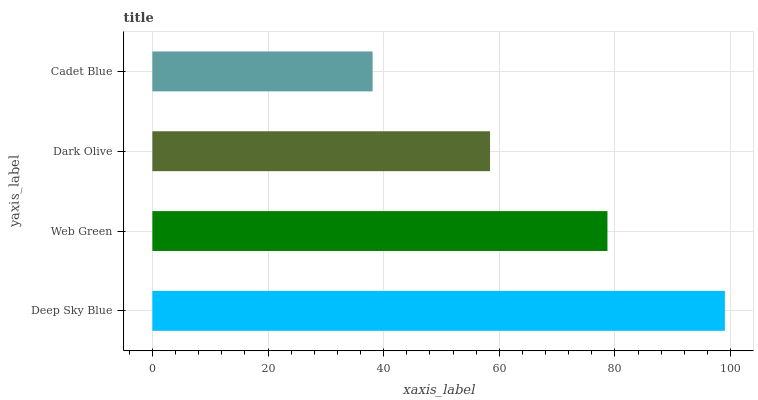Is Cadet Blue the minimum?
Answer yes or no. Yes. Is Deep Sky Blue the maximum?
Answer yes or no. Yes. Is Web Green the minimum?
Answer yes or no. No. Is Web Green the maximum?
Answer yes or no. No. Is Deep Sky Blue greater than Web Green?
Answer yes or no. Yes. Is Web Green less than Deep Sky Blue?
Answer yes or no. Yes. Is Web Green greater than Deep Sky Blue?
Answer yes or no. No. Is Deep Sky Blue less than Web Green?
Answer yes or no. No. Is Web Green the high median?
Answer yes or no. Yes. Is Dark Olive the low median?
Answer yes or no. Yes. Is Cadet Blue the high median?
Answer yes or no. No. Is Deep Sky Blue the low median?
Answer yes or no. No. 